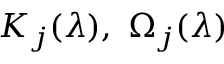<formula> <loc_0><loc_0><loc_500><loc_500>{ K } _ { j } ( { \boldsymbol \lambda } ) , \ \Omega _ { j } ( { \boldsymbol \lambda } )</formula> 